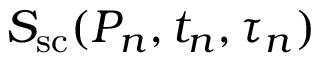Convert formula to latex. <formula><loc_0><loc_0><loc_500><loc_500>S _ { s c } ( P _ { n } , t _ { n } , \tau _ { n } )</formula> 